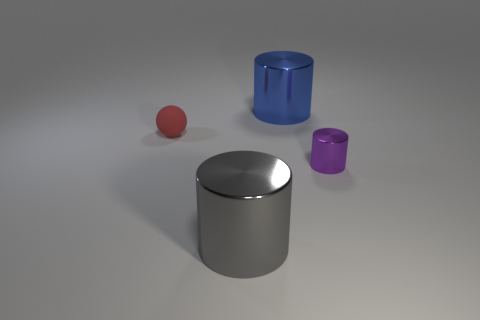The thing that is both to the left of the big blue metal cylinder and in front of the tiny rubber sphere has what shape?
Provide a short and direct response. Cylinder. What color is the metallic thing that is the same size as the gray shiny cylinder?
Offer a very short reply. Blue. Does the shiny thing that is right of the blue shiny cylinder have the same size as the cylinder that is behind the tiny red rubber sphere?
Give a very brief answer. No. What is the material of the object that is both on the left side of the big blue shiny cylinder and behind the purple object?
Keep it short and to the point. Rubber. How many other objects are the same size as the purple metallic cylinder?
Ensure brevity in your answer.  1. There is a large object behind the gray cylinder; what material is it?
Your answer should be compact. Metal. Do the blue object and the gray metallic thing have the same shape?
Give a very brief answer. Yes. What number of other objects are there of the same shape as the purple metal thing?
Offer a terse response. 2. What is the color of the large metallic cylinder that is in front of the purple shiny thing?
Ensure brevity in your answer.  Gray. Does the red rubber object have the same size as the gray cylinder?
Ensure brevity in your answer.  No. 